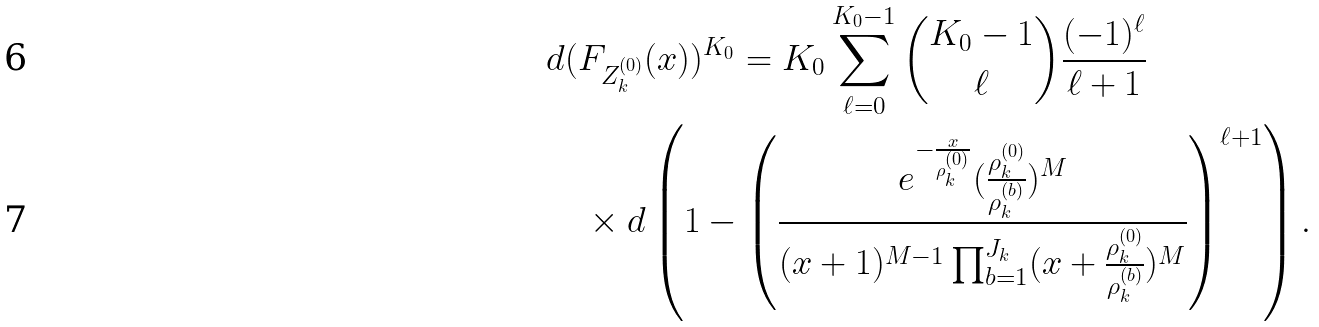<formula> <loc_0><loc_0><loc_500><loc_500>& d ( F _ { Z _ { k } ^ { ( 0 ) } } ( x ) ) ^ { K _ { 0 } } = K _ { 0 } \sum _ { \ell = 0 } ^ { K _ { 0 } - 1 } { K _ { 0 } - 1 \choose \ell } \frac { ( - 1 ) ^ { \ell } } { \ell + 1 } \\ & \quad \times d \left ( 1 - \left ( \frac { e ^ { - \frac { x } { \rho _ { k } ^ { ( 0 ) } } } ( \frac { \rho _ { k } ^ { ( 0 ) } } { \rho _ { k } ^ { ( b ) } } ) ^ { M } } { ( x + 1 ) ^ { M - 1 } \prod _ { b = 1 } ^ { J _ { k } } ( x + \frac { \rho _ { k } ^ { ( 0 ) } } { \rho _ { k } ^ { ( b ) } } ) ^ { M } } \right ) ^ { \ell + 1 } \right ) .</formula> 